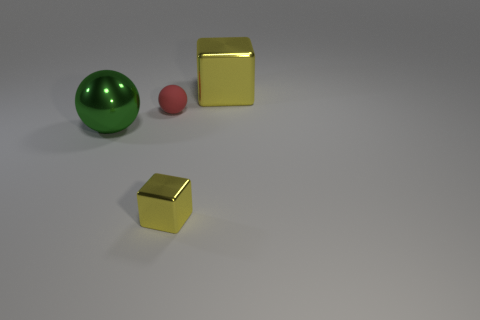Add 4 large yellow metallic objects. How many objects exist? 8 Subtract 0 purple spheres. How many objects are left? 4 Subtract all large shiny blocks. Subtract all small shiny things. How many objects are left? 2 Add 3 large yellow shiny cubes. How many large yellow shiny cubes are left? 4 Add 2 rubber objects. How many rubber objects exist? 3 